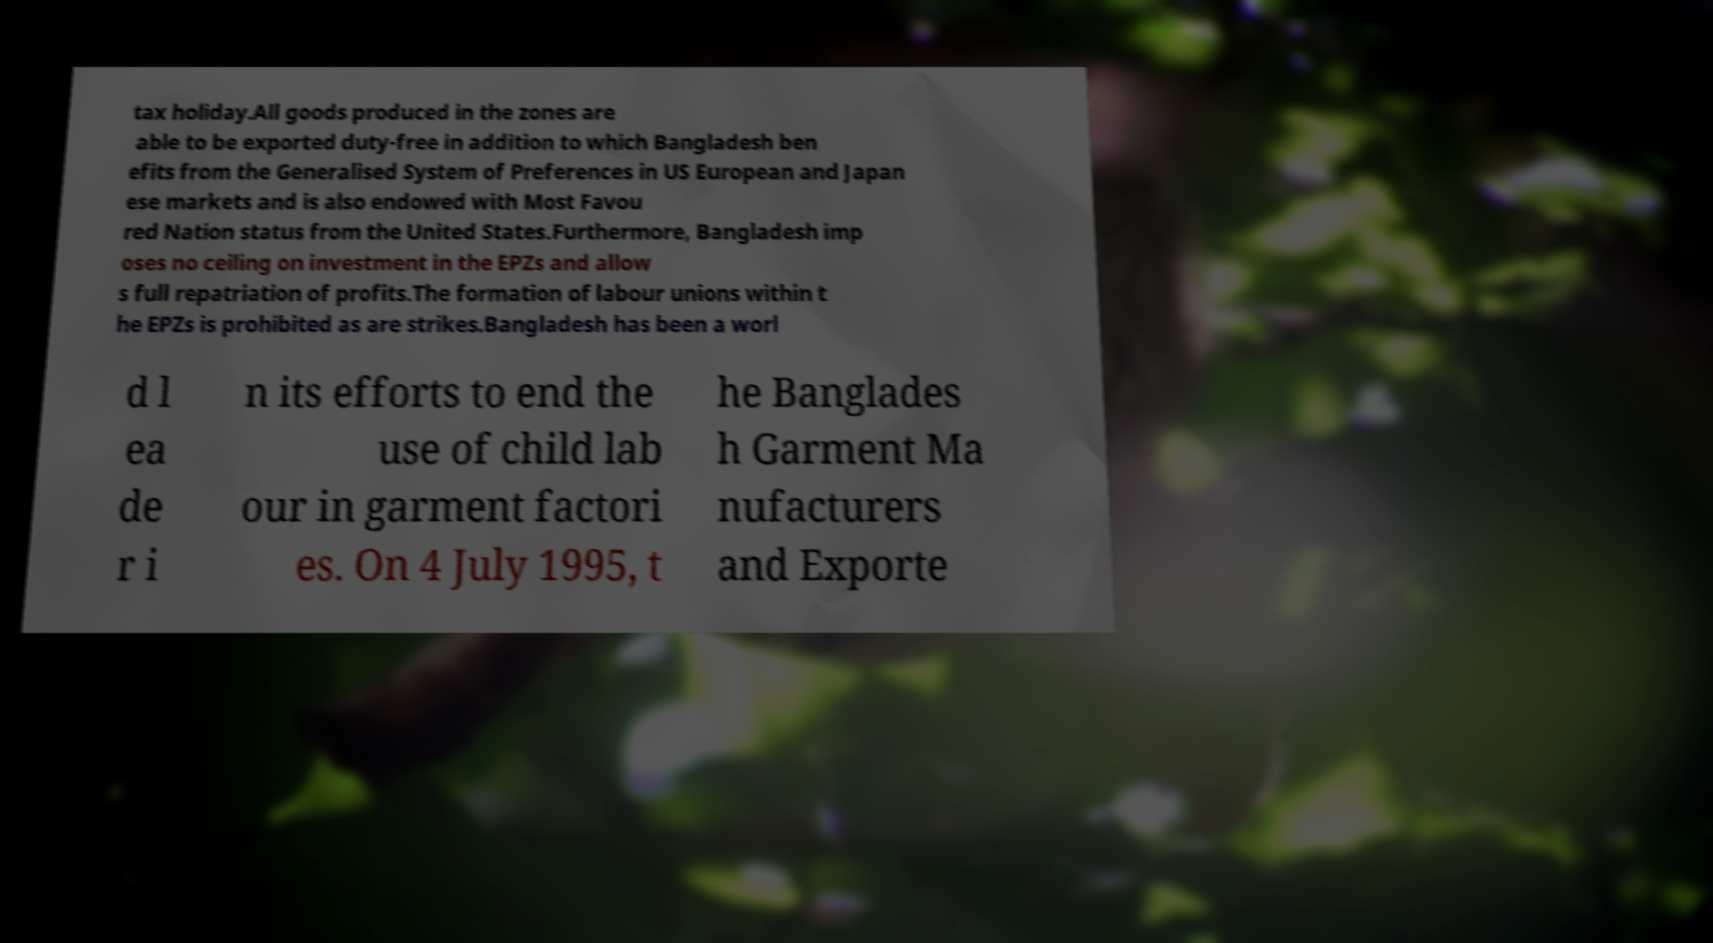Can you accurately transcribe the text from the provided image for me? tax holiday.All goods produced in the zones are able to be exported duty-free in addition to which Bangladesh ben efits from the Generalised System of Preferences in US European and Japan ese markets and is also endowed with Most Favou red Nation status from the United States.Furthermore, Bangladesh imp oses no ceiling on investment in the EPZs and allow s full repatriation of profits.The formation of labour unions within t he EPZs is prohibited as are strikes.Bangladesh has been a worl d l ea de r i n its efforts to end the use of child lab our in garment factori es. On 4 July 1995, t he Banglades h Garment Ma nufacturers and Exporte 